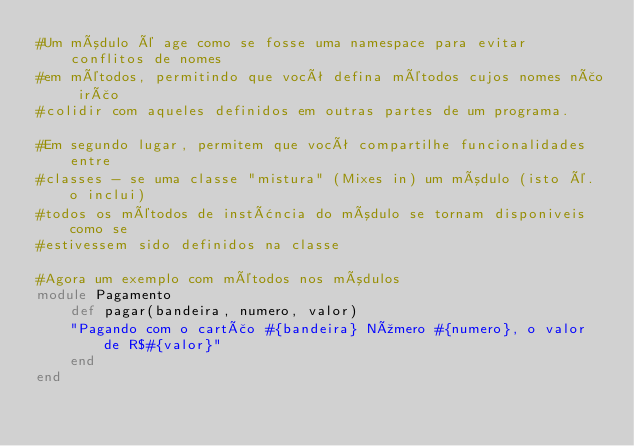Convert code to text. <code><loc_0><loc_0><loc_500><loc_500><_Ruby_>#Um módulo é age como se fosse uma namespace para evitar conflitos de nomes
#em métodos, permitindo que você defina métodos cujos nomes não irão
#colidir com aqueles definidos em outras partes de um programa.

#Em segundo lugar, permitem que você compartilhe funcionalidades entre
#classes - se uma classe "mistura" (Mixes in) um módulo (isto é. o inclui)
#todos os métodos de instância do módulo se tornam disponiveis como se
#estivessem sido definidos na classe

#Agora um exemplo com métodos nos módulos
module Pagamento
    def pagar(bandeira, numero, valor)
    "Pagando com o cartão #{bandeira} Número #{numero}, o valor de R$#{valor}"
    end
end</code> 